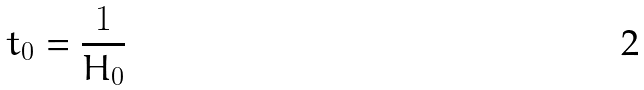<formula> <loc_0><loc_0><loc_500><loc_500>t _ { 0 } = \frac { 1 } { H _ { 0 } }</formula> 